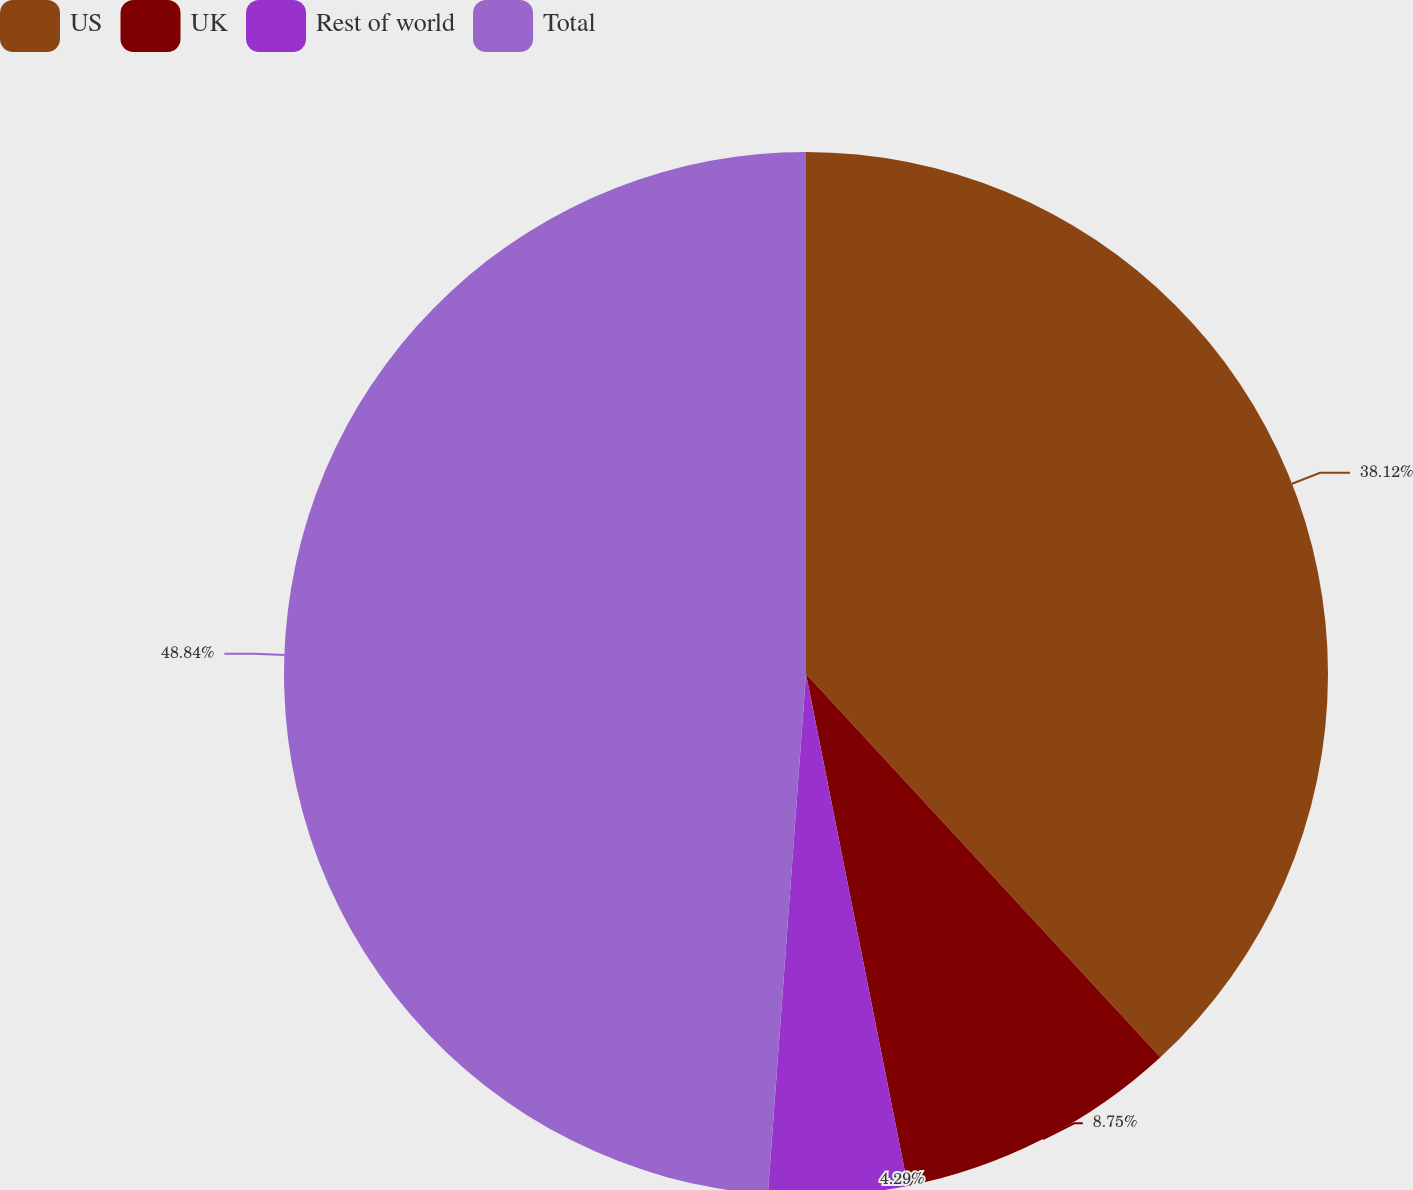<chart> <loc_0><loc_0><loc_500><loc_500><pie_chart><fcel>US<fcel>UK<fcel>Rest of world<fcel>Total<nl><fcel>38.12%<fcel>8.75%<fcel>4.29%<fcel>48.83%<nl></chart> 